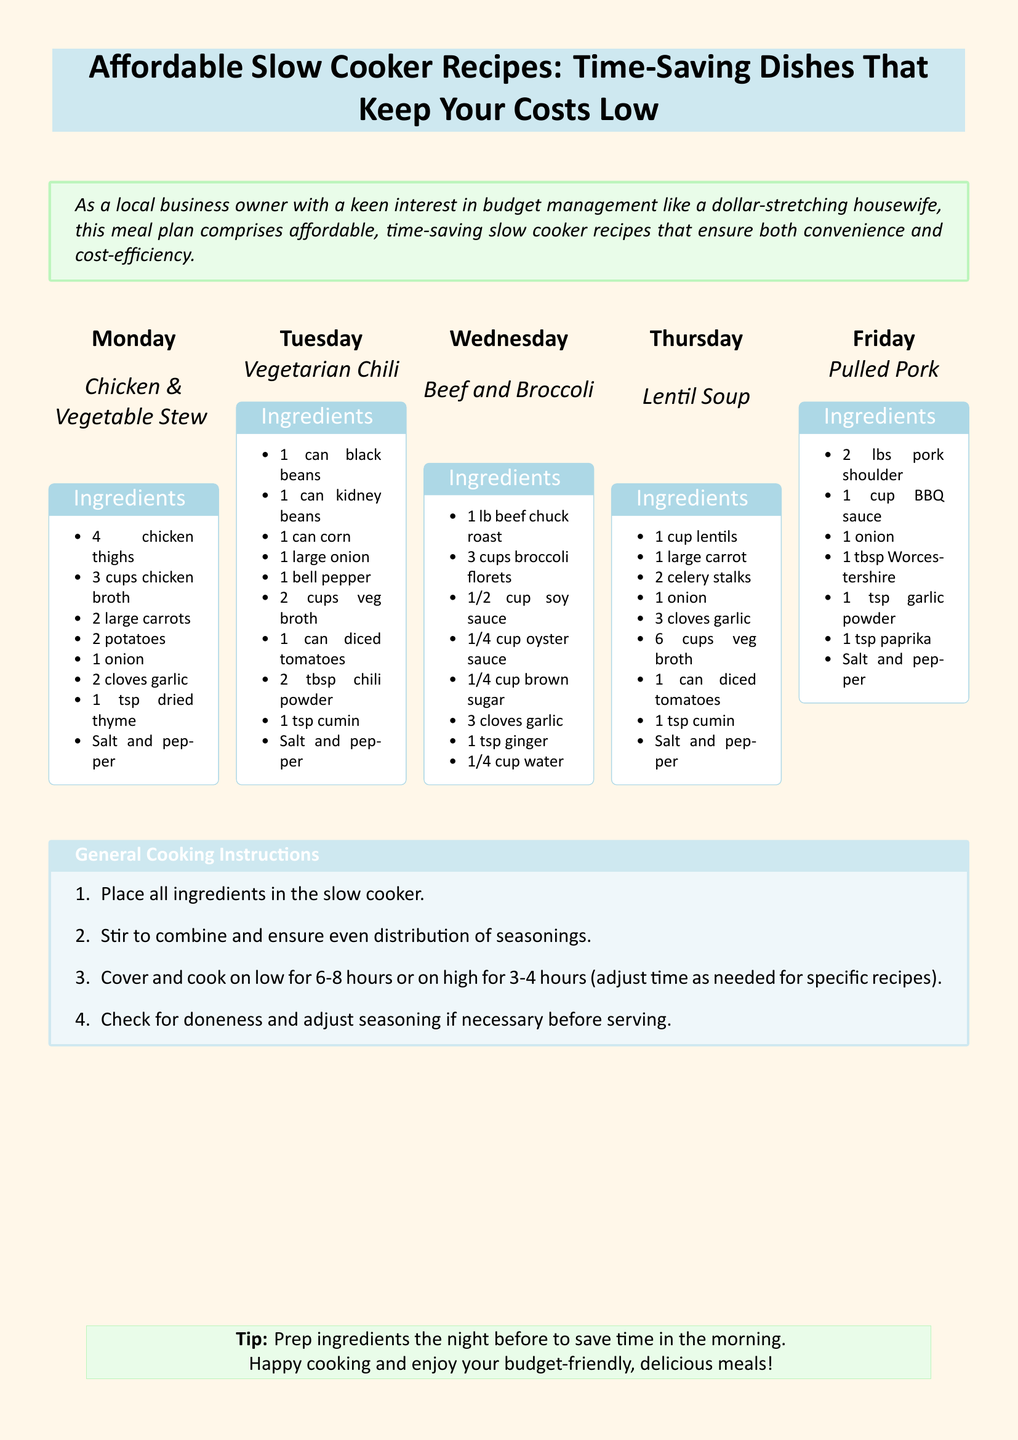What is the title of the document? The title is presented in the header of the document.
Answer: Affordable Slow Cooker Recipes: Time-Saving Dishes That Keep Your Costs Low What is the main ingredient for Tuesday's recipe? The recipe for Tuesday is Vegetarian Chili, which includes black beans, kidney beans, and corn.
Answer: black beans How many cups of chicken broth are needed for the Chicken & Vegetable Stew? The required amount of chicken broth is specified in the ingredients list for the Chicken & Vegetable Stew.
Answer: 3 cups What cooking method is suggested for all recipes? The document specifies a general cooking method that applies to all recipes.
Answer: Slow cooking How many hours is it recommended to cook on high? The cooking time on high is included in the general cooking instructions.
Answer: 3-4 hours What day features a dish with pork? The specific day for the dish Pulled Pork is mentioned in the document.
Answer: Friday How many cups of vegetable broth are in the Vegetarian Chili? The ingredients list for Vegetarian Chili shows the amount of vegetable broth required.
Answer: 2 cups What is a recommended tip for saving time? The document includes a specific tip to help with meal preparation.
Answer: Prep ingredients the night before Which recipe features lentils? The recipe including lentils is specified in the meal plan for Thursday.
Answer: Lentil Soup 